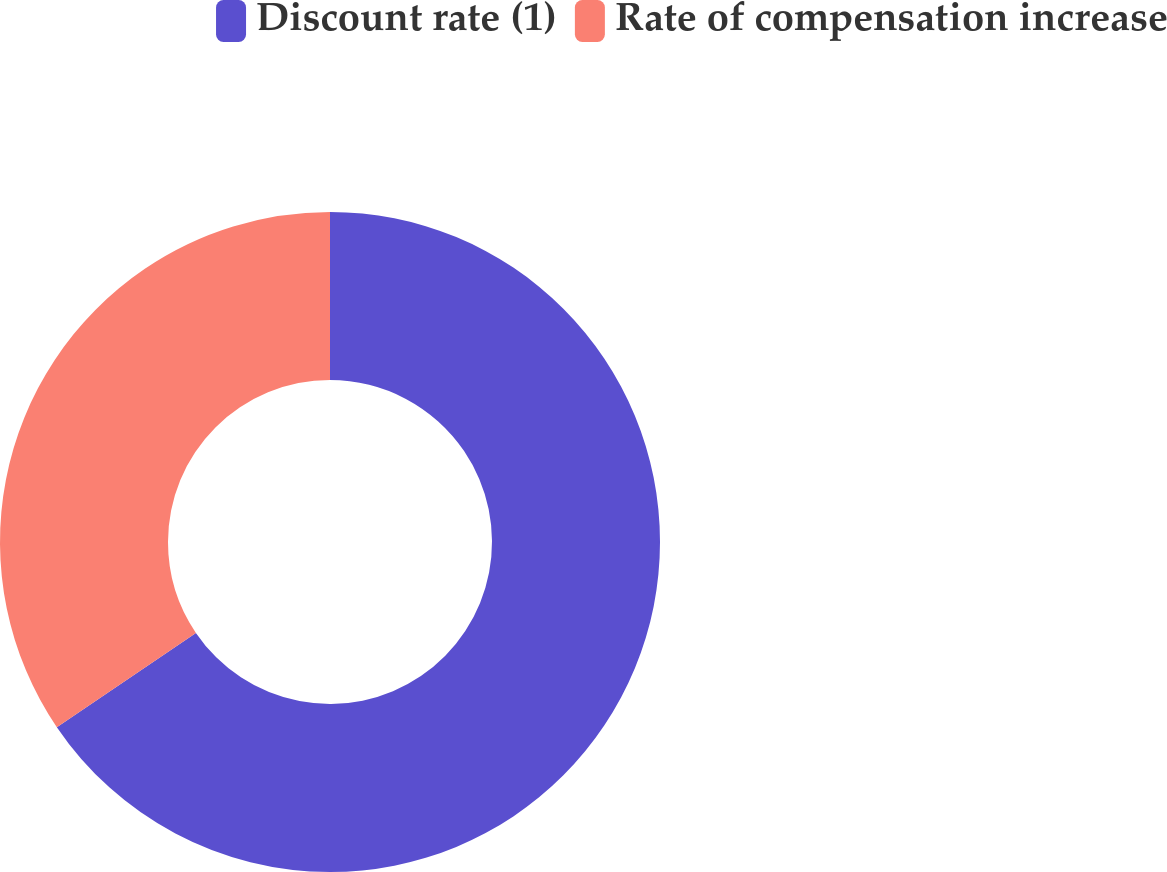Convert chart to OTSL. <chart><loc_0><loc_0><loc_500><loc_500><pie_chart><fcel>Discount rate (1)<fcel>Rate of compensation increase<nl><fcel>65.52%<fcel>34.48%<nl></chart> 